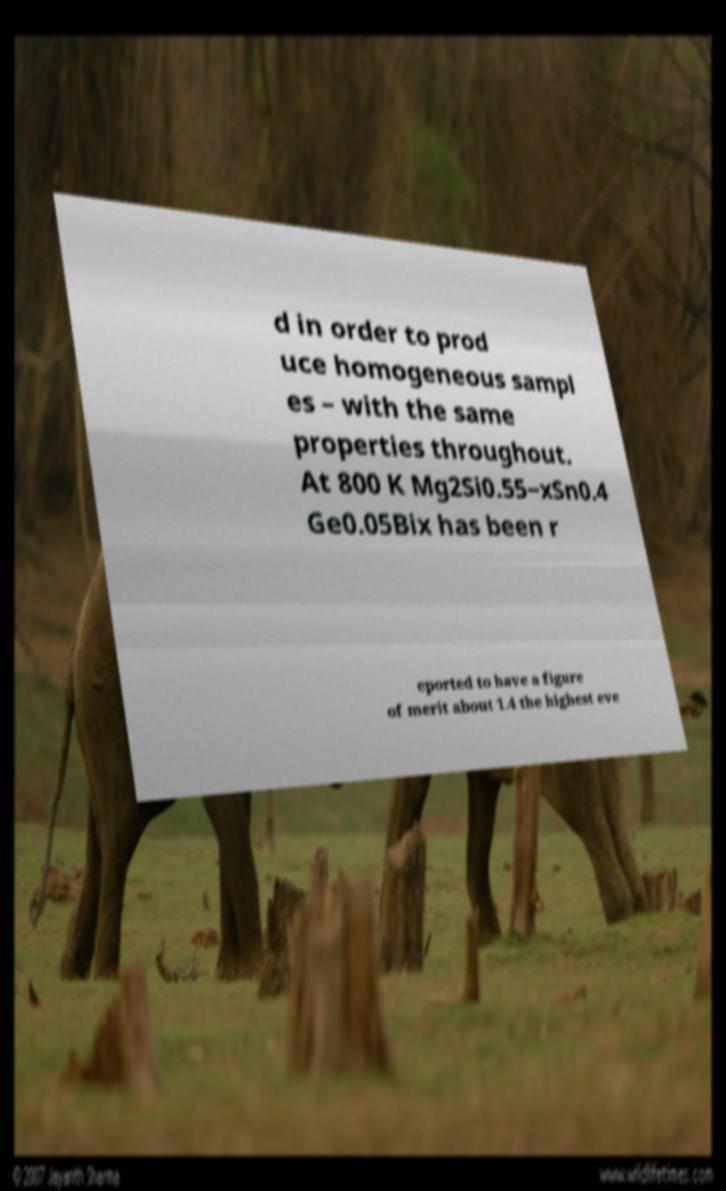Can you read and provide the text displayed in the image?This photo seems to have some interesting text. Can you extract and type it out for me? d in order to prod uce homogeneous sampl es – with the same properties throughout. At 800 K Mg2Si0.55−xSn0.4 Ge0.05Bix has been r eported to have a figure of merit about 1.4 the highest eve 